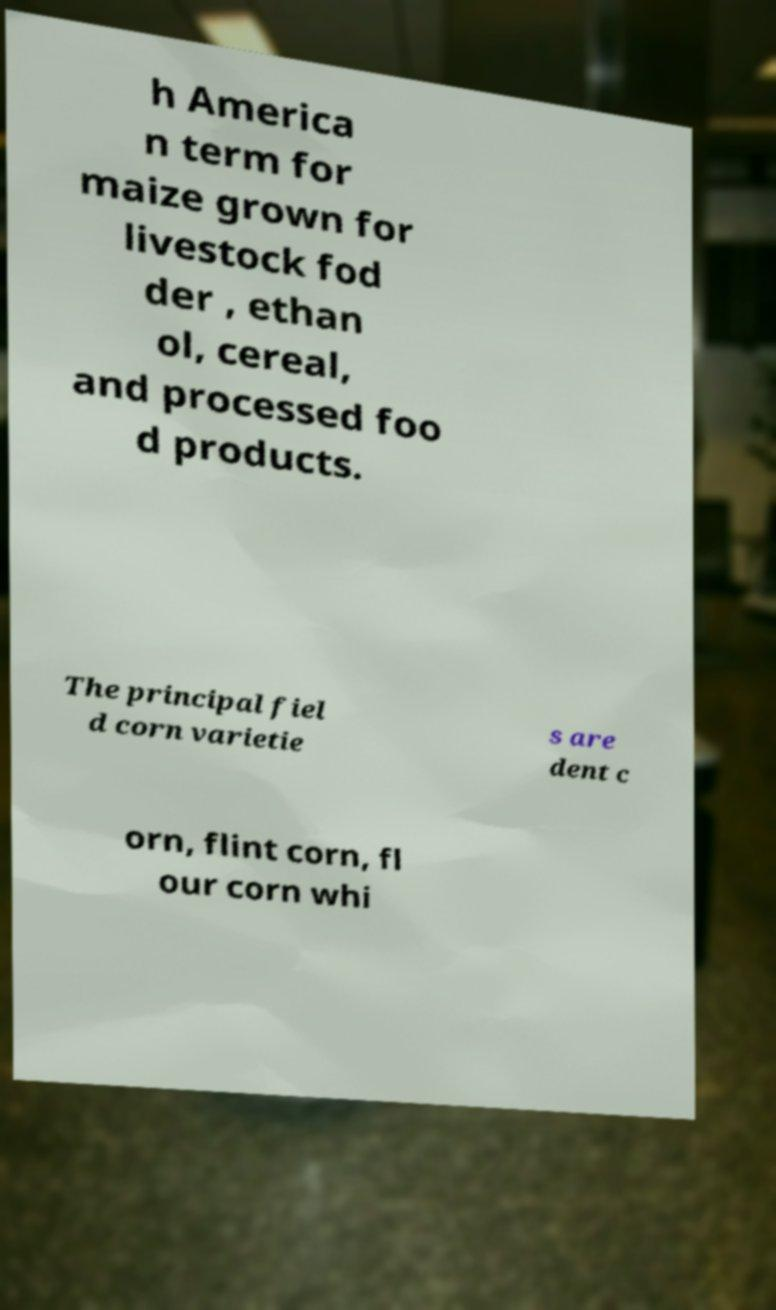There's text embedded in this image that I need extracted. Can you transcribe it verbatim? h America n term for maize grown for livestock fod der , ethan ol, cereal, and processed foo d products. The principal fiel d corn varietie s are dent c orn, flint corn, fl our corn whi 